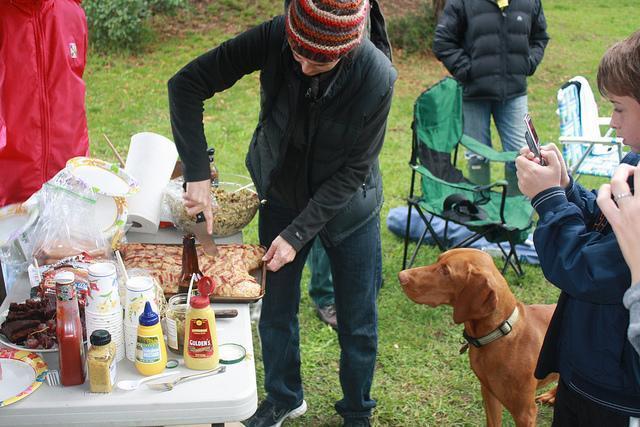How many bottles are in the picture?
Give a very brief answer. 2. How many chairs are there?
Give a very brief answer. 2. How many people are in the photo?
Give a very brief answer. 5. 